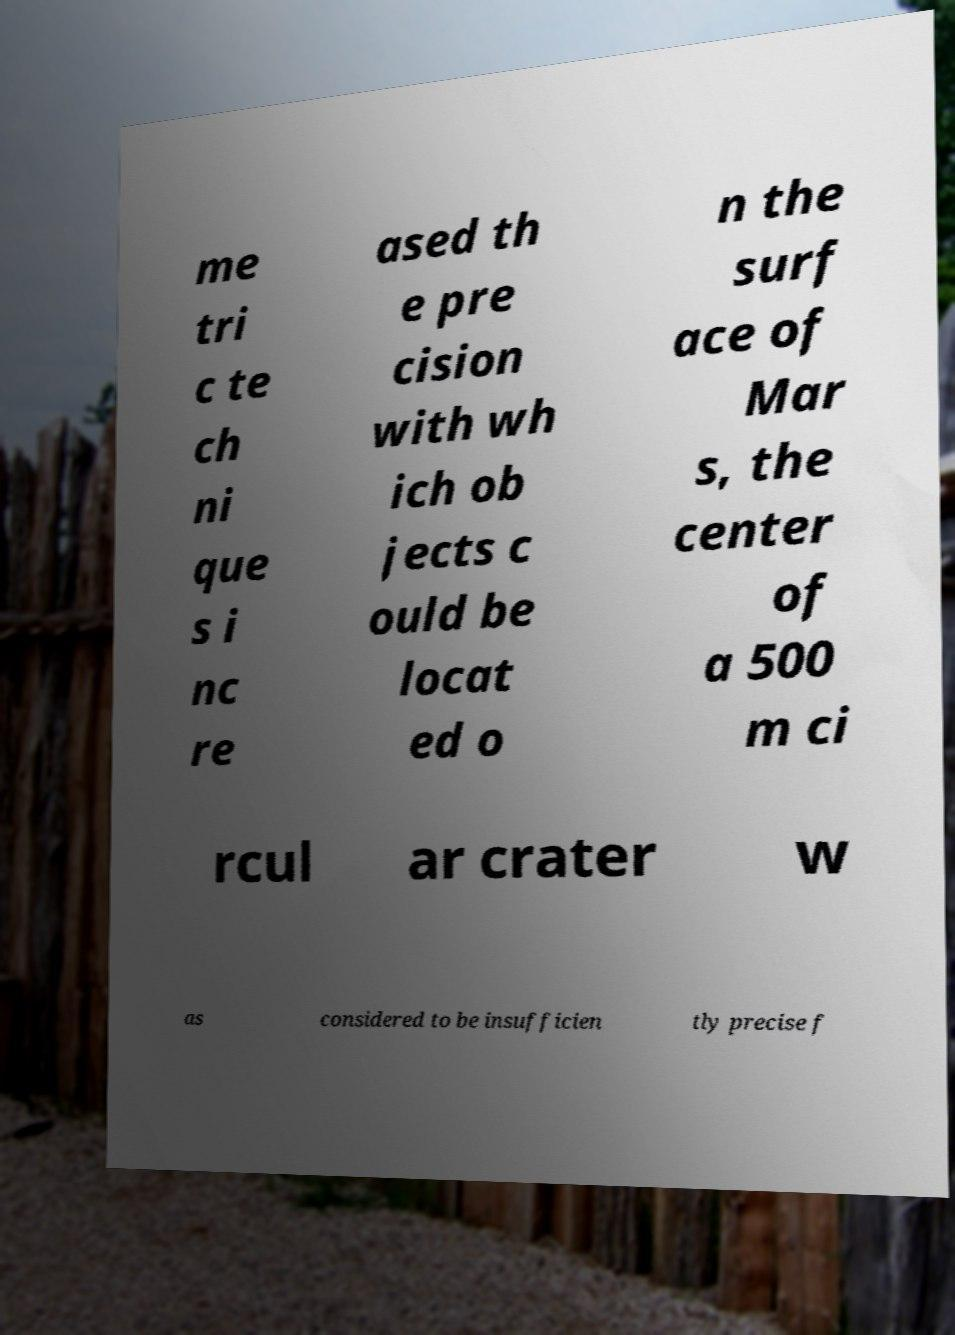Could you assist in decoding the text presented in this image and type it out clearly? me tri c te ch ni que s i nc re ased th e pre cision with wh ich ob jects c ould be locat ed o n the surf ace of Mar s, the center of a 500 m ci rcul ar crater w as considered to be insufficien tly precise f 